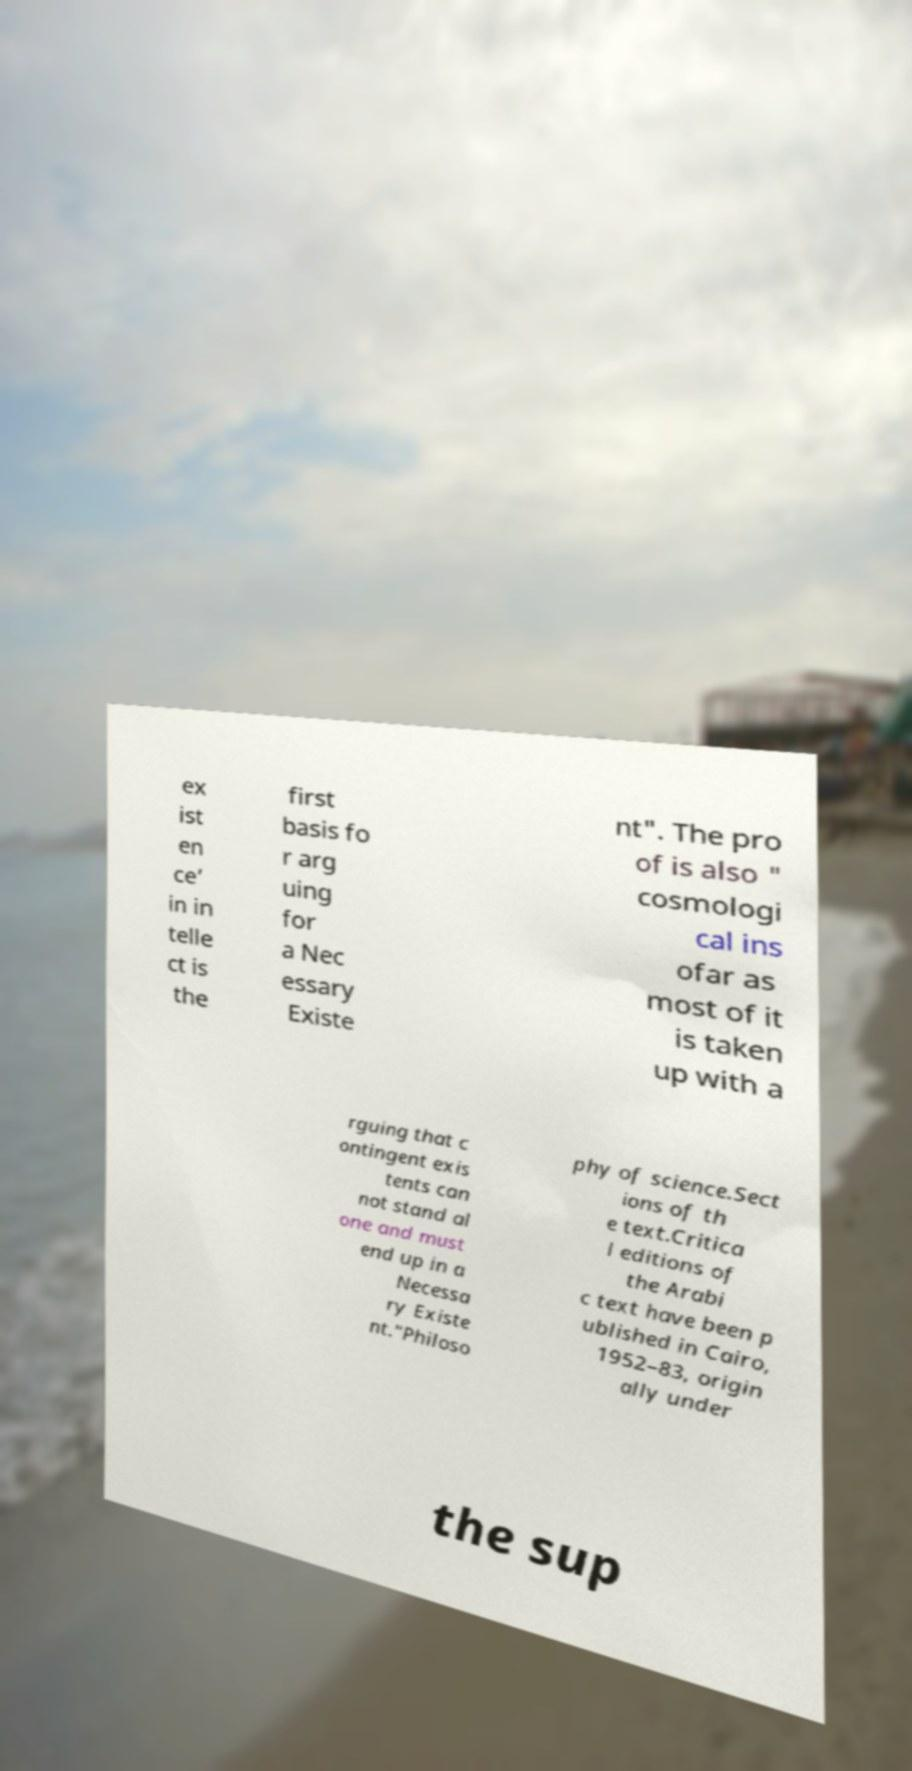Can you read and provide the text displayed in the image?This photo seems to have some interesting text. Can you extract and type it out for me? ex ist en ce’ in in telle ct is the first basis fo r arg uing for a Nec essary Existe nt". The pro of is also " cosmologi cal ins ofar as most of it is taken up with a rguing that c ontingent exis tents can not stand al one and must end up in a Necessa ry Existe nt."Philoso phy of science.Sect ions of th e text.Critica l editions of the Arabi c text have been p ublished in Cairo, 1952–83, origin ally under the sup 